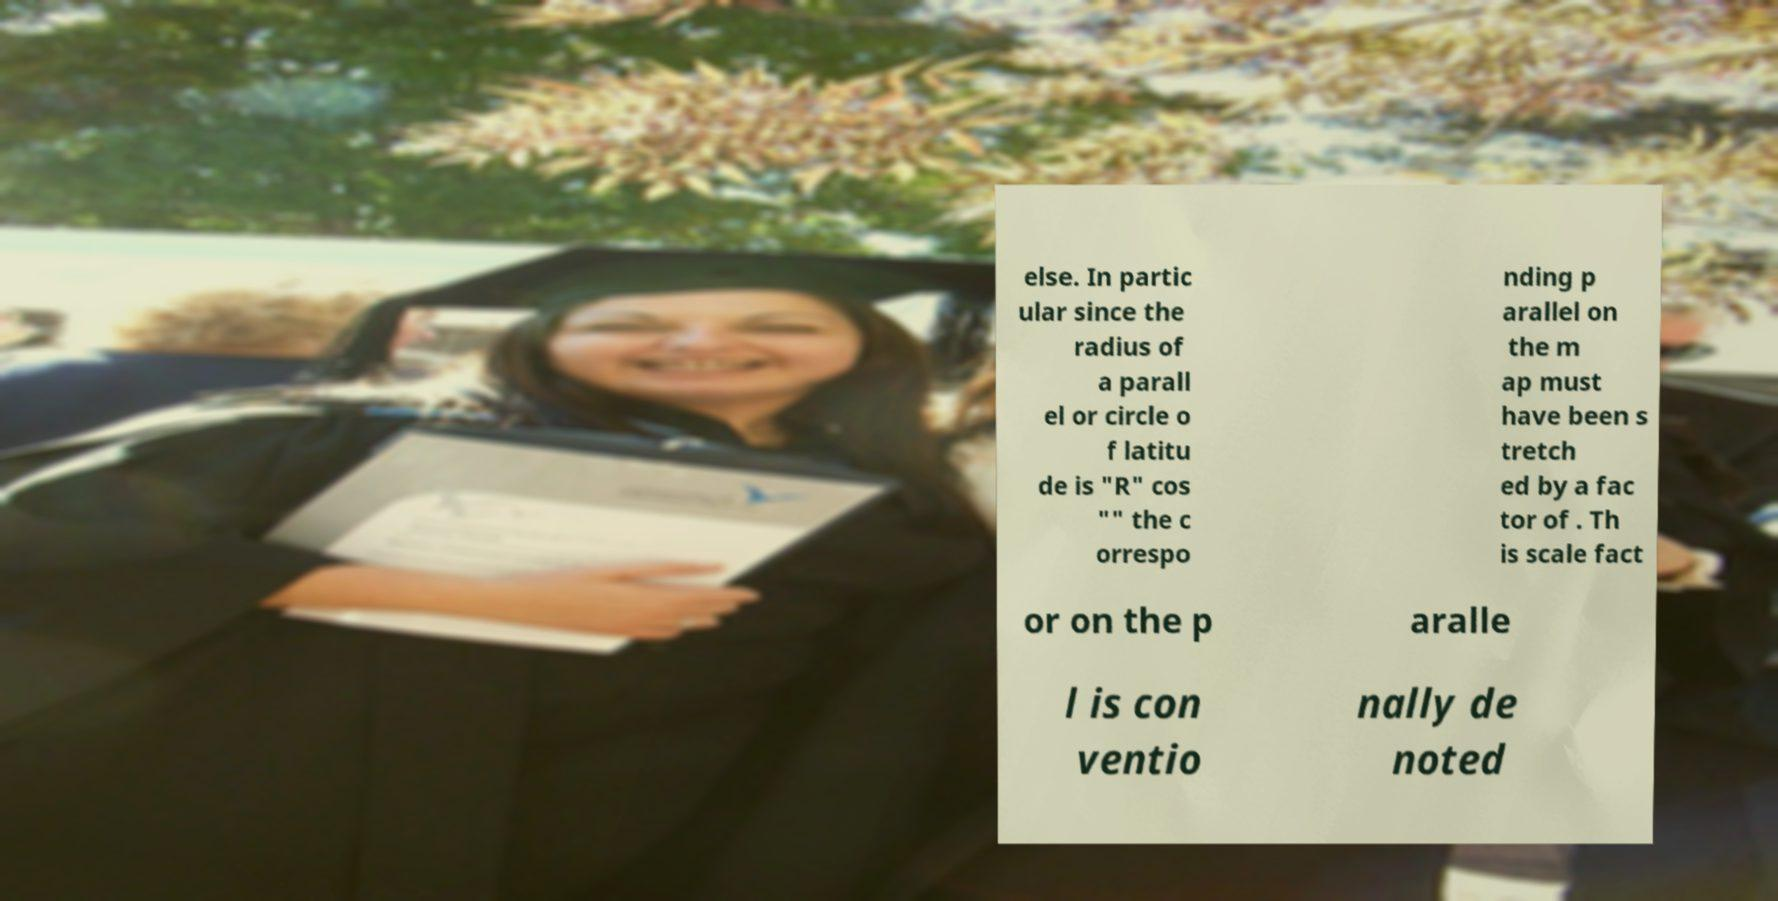Could you extract and type out the text from this image? else. In partic ular since the radius of a parall el or circle o f latitu de is "R" cos "" the c orrespo nding p arallel on the m ap must have been s tretch ed by a fac tor of . Th is scale fact or on the p aralle l is con ventio nally de noted 